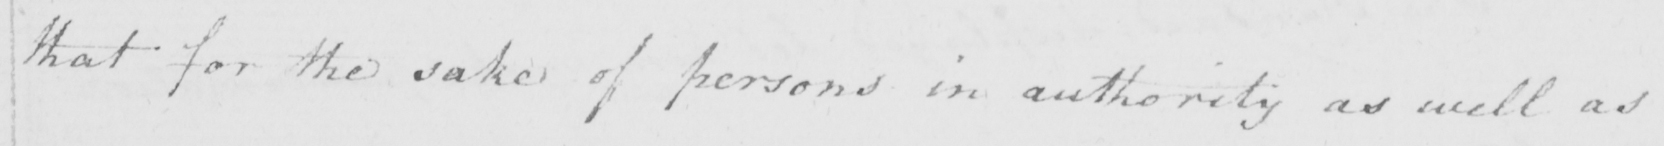Transcribe the text shown in this historical manuscript line. that for the sake of persons in authority as well as 